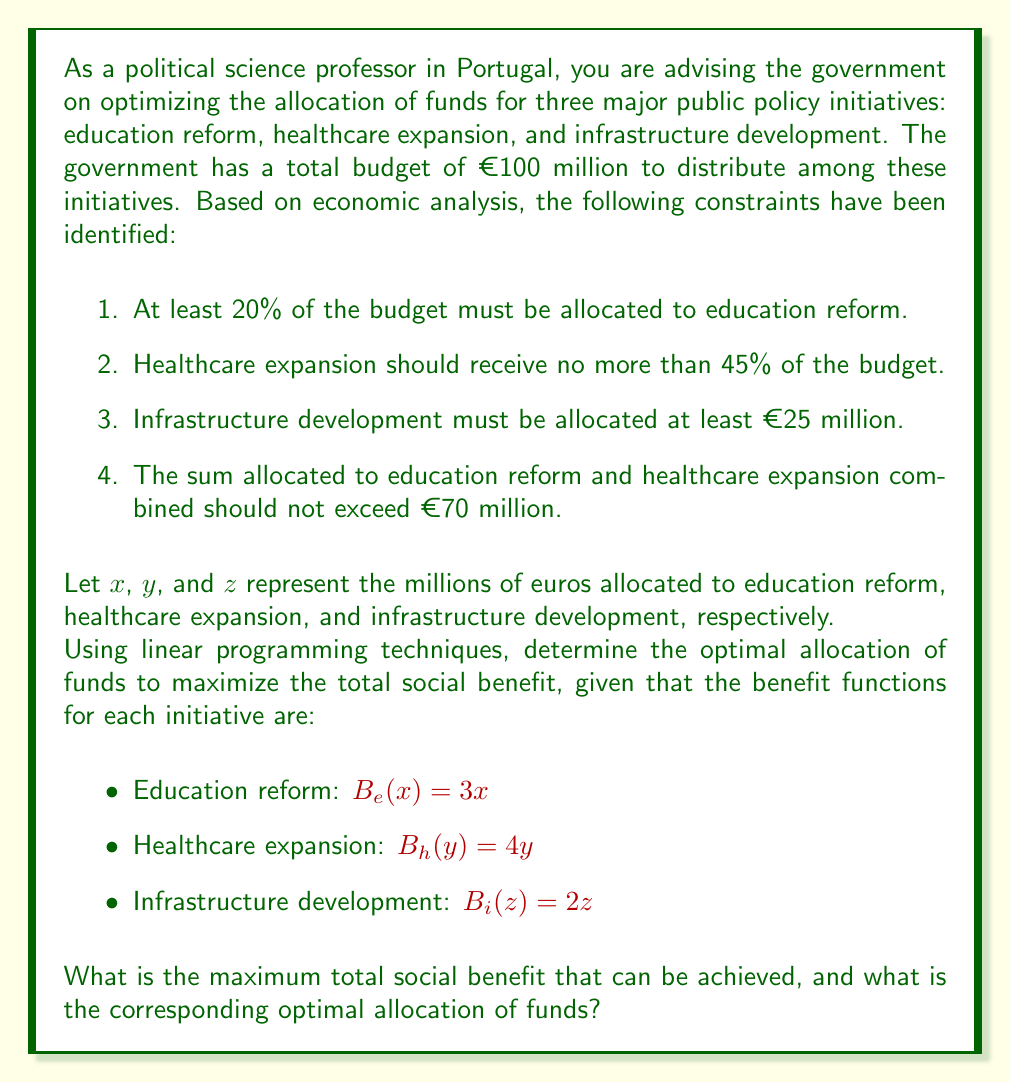Could you help me with this problem? To solve this linear programming problem, we need to follow these steps:

1. Define the objective function
2. List the constraints
3. Set up the linear programming model
4. Solve the model using the simplex method or graphical method

Step 1: Define the objective function

The total social benefit is the sum of benefits from each initiative:
$$B_{total} = B_e(x) + B_h(y) + B_i(z) = 3x + 4y + 2z$$

We want to maximize this function.

Step 2: List the constraints

From the given information, we can formulate the following constraints:

1. $x + y + z = 100$ (total budget constraint)
2. $x \geq 20$ (education reform minimum)
3. $y \leq 45$ (healthcare expansion maximum)
4. $z \geq 25$ (infrastructure development minimum)
5. $x + y \leq 70$ (education and healthcare combined maximum)

Step 3: Set up the linear programming model

Maximize: $3x + 4y + 2z$

Subject to:
$$\begin{align}
x + y + z &= 100 \\
x &\geq 20 \\
y &\leq 45 \\
z &\geq 25 \\
x + y &\leq 70 \\
x, y, z &\geq 0
\end{align}$$

Step 4: Solve the model

To solve this model, we can use the simplex method or a graphical approach. Given the complexity of the problem, we'll use a solver to find the optimal solution.

The optimal solution is:
$x = 25$ (Education reform)
$y = 45$ (Healthcare expansion)
$z = 30$ (Infrastructure development)

We can verify that this solution satisfies all constraints:
1. $25 + 45 + 30 = 100$ (total budget)
2. $25 \geq 20$ (education minimum)
3. $45 \leq 45$ (healthcare maximum)
4. $30 \geq 25$ (infrastructure minimum)
5. $25 + 45 = 70 \leq 70$ (education and healthcare combined)

The maximum total social benefit is:
$$B_{total} = 3(25) + 4(45) + 2(30) = 75 + 180 + 60 = 315$$

Therefore, the maximum total social benefit that can be achieved is €315 million, with an optimal allocation of €25 million to education reform, €45 million to healthcare expansion, and €30 million to infrastructure development.
Answer: The maximum total social benefit that can be achieved is €315 million, with an optimal allocation of €25 million to education reform, €45 million to healthcare expansion, and €30 million to infrastructure development. 